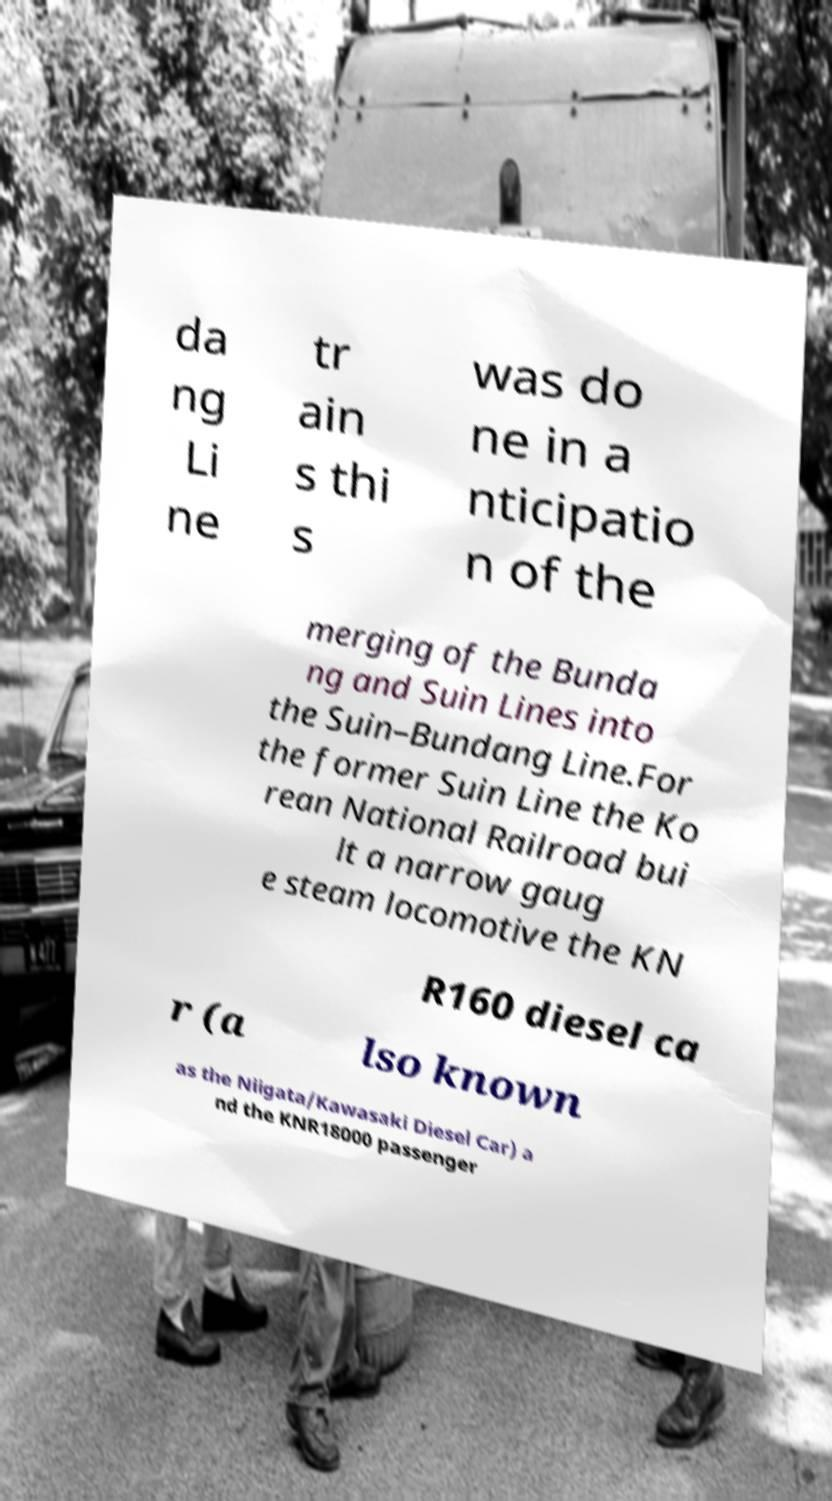Could you extract and type out the text from this image? da ng Li ne tr ain s thi s was do ne in a nticipatio n of the merging of the Bunda ng and Suin Lines into the Suin–Bundang Line.For the former Suin Line the Ko rean National Railroad bui lt a narrow gaug e steam locomotive the KN R160 diesel ca r (a lso known as the Niigata/Kawasaki Diesel Car) a nd the KNR18000 passenger 